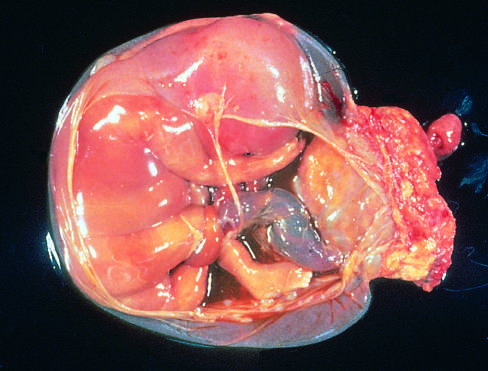does the blue area extend from the portion of the amniotic sac to encircle the leg of the fetus?
Answer the question using a single word or phrase. No 